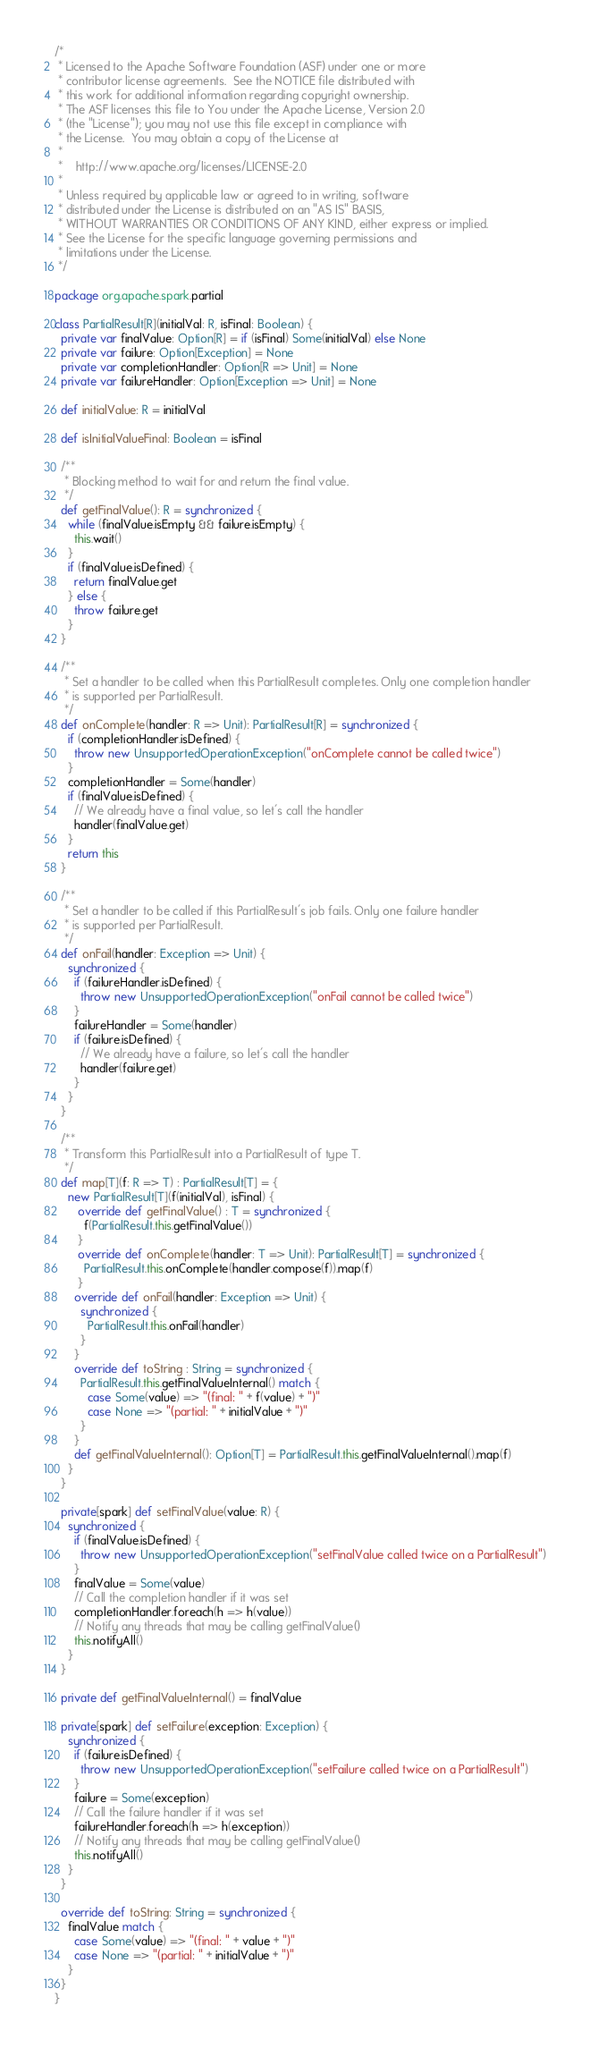<code> <loc_0><loc_0><loc_500><loc_500><_Scala_>/*
 * Licensed to the Apache Software Foundation (ASF) under one or more
 * contributor license agreements.  See the NOTICE file distributed with
 * this work for additional information regarding copyright ownership.
 * The ASF licenses this file to You under the Apache License, Version 2.0
 * (the "License"); you may not use this file except in compliance with
 * the License.  You may obtain a copy of the License at
 *
 *    http://www.apache.org/licenses/LICENSE-2.0
 *
 * Unless required by applicable law or agreed to in writing, software
 * distributed under the License is distributed on an "AS IS" BASIS,
 * WITHOUT WARRANTIES OR CONDITIONS OF ANY KIND, either express or implied.
 * See the License for the specific language governing permissions and
 * limitations under the License.
 */

package org.apache.spark.partial

class PartialResult[R](initialVal: R, isFinal: Boolean) {
  private var finalValue: Option[R] = if (isFinal) Some(initialVal) else None
  private var failure: Option[Exception] = None
  private var completionHandler: Option[R => Unit] = None
  private var failureHandler: Option[Exception => Unit] = None

  def initialValue: R = initialVal

  def isInitialValueFinal: Boolean = isFinal

  /**
   * Blocking method to wait for and return the final value.
   */
  def getFinalValue(): R = synchronized {
    while (finalValue.isEmpty && failure.isEmpty) {
      this.wait()
    }
    if (finalValue.isDefined) {
      return finalValue.get
    } else {
      throw failure.get
    }
  }

  /**
   * Set a handler to be called when this PartialResult completes. Only one completion handler
   * is supported per PartialResult.
   */
  def onComplete(handler: R => Unit): PartialResult[R] = synchronized {
    if (completionHandler.isDefined) {
      throw new UnsupportedOperationException("onComplete cannot be called twice")
    }
    completionHandler = Some(handler)
    if (finalValue.isDefined) {
      // We already have a final value, so let's call the handler
      handler(finalValue.get)
    }
    return this
  }

  /**
   * Set a handler to be called if this PartialResult's job fails. Only one failure handler
   * is supported per PartialResult.
   */
  def onFail(handler: Exception => Unit) {
    synchronized {
      if (failureHandler.isDefined) {
        throw new UnsupportedOperationException("onFail cannot be called twice")
      }
      failureHandler = Some(handler)
      if (failure.isDefined) {
        // We already have a failure, so let's call the handler
        handler(failure.get)
      }
    }
  }

  /**
   * Transform this PartialResult into a PartialResult of type T.
   */
  def map[T](f: R => T) : PartialResult[T] = {
    new PartialResult[T](f(initialVal), isFinal) {
       override def getFinalValue() : T = synchronized {
         f(PartialResult.this.getFinalValue())
       }
       override def onComplete(handler: T => Unit): PartialResult[T] = synchronized {
         PartialResult.this.onComplete(handler.compose(f)).map(f)
       }
      override def onFail(handler: Exception => Unit) {
        synchronized {
          PartialResult.this.onFail(handler)
        }
      }
      override def toString : String = synchronized {
        PartialResult.this.getFinalValueInternal() match {
          case Some(value) => "(final: " + f(value) + ")"
          case None => "(partial: " + initialValue + ")"
        }
      }
      def getFinalValueInternal(): Option[T] = PartialResult.this.getFinalValueInternal().map(f)
    }
  }

  private[spark] def setFinalValue(value: R) {
    synchronized {
      if (finalValue.isDefined) {
        throw new UnsupportedOperationException("setFinalValue called twice on a PartialResult")
      }
      finalValue = Some(value)
      // Call the completion handler if it was set
      completionHandler.foreach(h => h(value))
      // Notify any threads that may be calling getFinalValue()
      this.notifyAll()
    }
  }

  private def getFinalValueInternal() = finalValue

  private[spark] def setFailure(exception: Exception) {
    synchronized {
      if (failure.isDefined) {
        throw new UnsupportedOperationException("setFailure called twice on a PartialResult")
      }
      failure = Some(exception)
      // Call the failure handler if it was set
      failureHandler.foreach(h => h(exception))
      // Notify any threads that may be calling getFinalValue()
      this.notifyAll()
    }
  }

  override def toString: String = synchronized {
    finalValue match {
      case Some(value) => "(final: " + value + ")"
      case None => "(partial: " + initialValue + ")"
    }
  }
}
</code> 